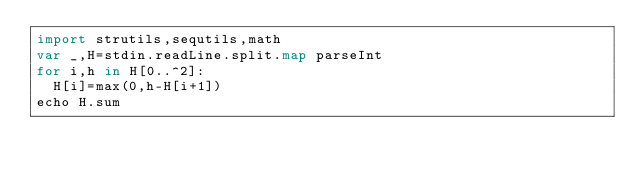<code> <loc_0><loc_0><loc_500><loc_500><_Nim_>import strutils,sequtils,math
var _,H=stdin.readLine.split.map parseInt
for i,h in H[0..^2]:
  H[i]=max(0,h-H[i+1])
echo H.sum</code> 